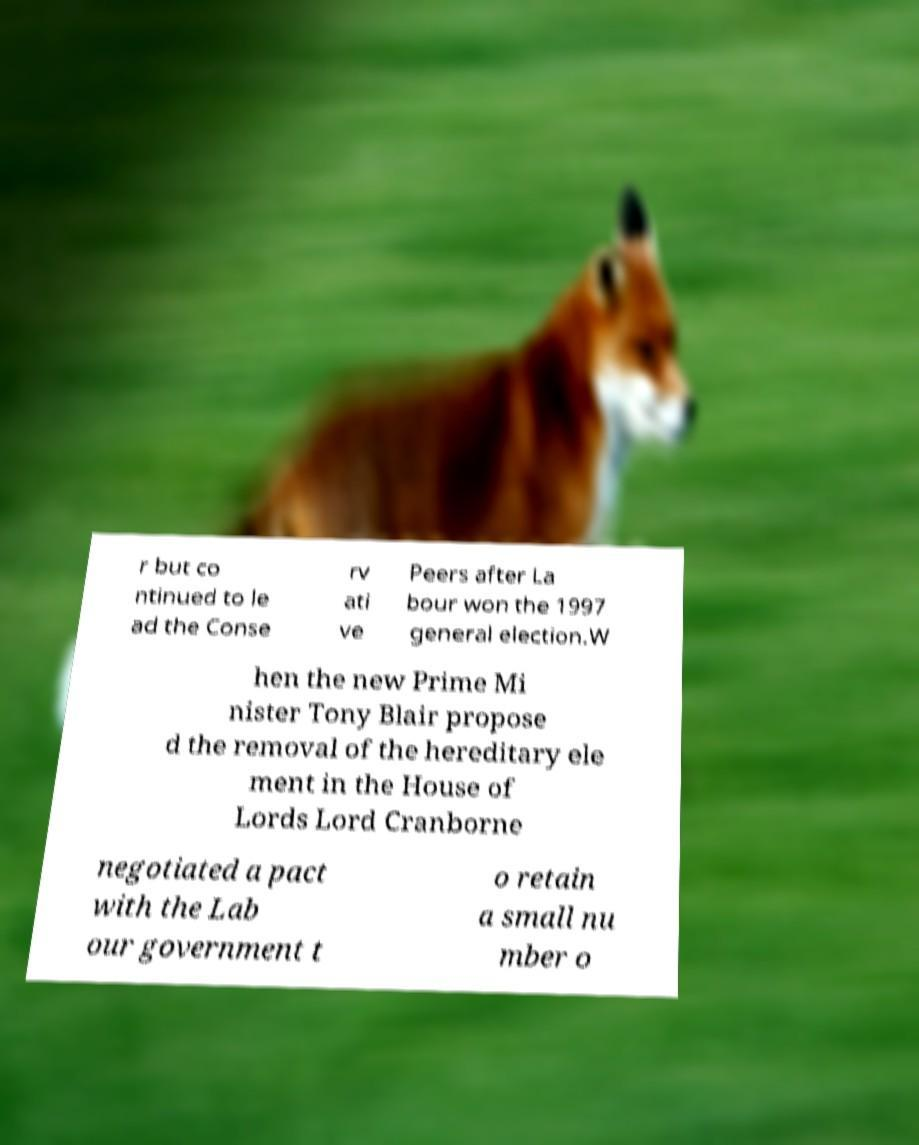What messages or text are displayed in this image? I need them in a readable, typed format. r but co ntinued to le ad the Conse rv ati ve Peers after La bour won the 1997 general election.W hen the new Prime Mi nister Tony Blair propose d the removal of the hereditary ele ment in the House of Lords Lord Cranborne negotiated a pact with the Lab our government t o retain a small nu mber o 